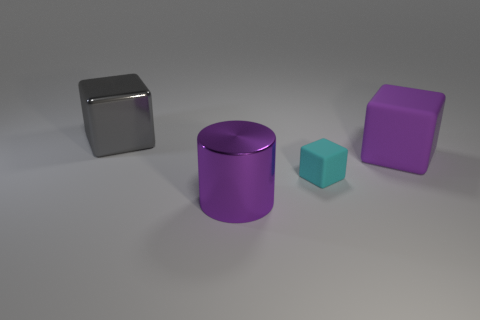Subtract all big matte blocks. How many blocks are left? 2 Subtract all cylinders. How many objects are left? 3 Subtract all gray cubes. How many cubes are left? 2 Subtract 0 gray cylinders. How many objects are left? 4 Subtract 2 blocks. How many blocks are left? 1 Subtract all gray cylinders. Subtract all gray balls. How many cylinders are left? 1 Subtract all cyan balls. How many gray blocks are left? 1 Subtract all gray objects. Subtract all small matte blocks. How many objects are left? 2 Add 1 big purple objects. How many big purple objects are left? 3 Add 1 gray metal objects. How many gray metal objects exist? 2 